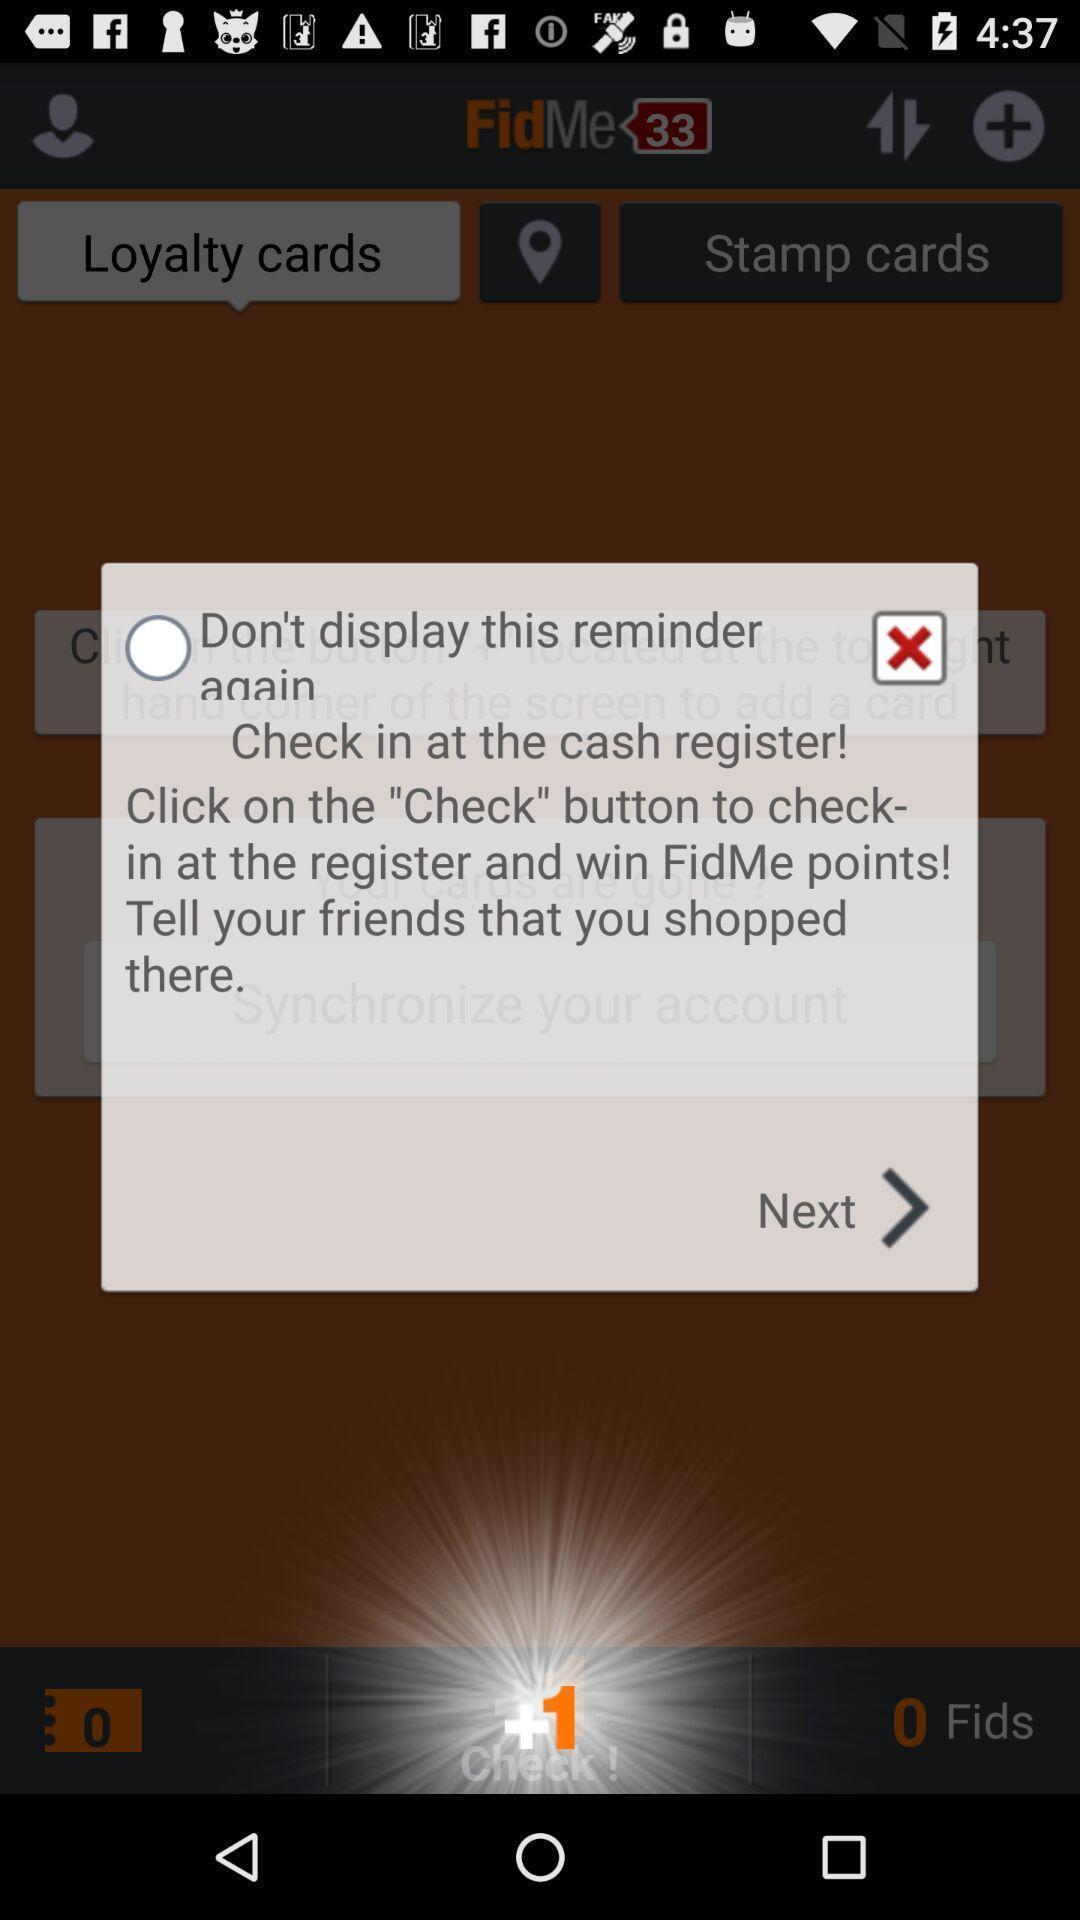Summarize the information in this screenshot. Pop-up to continue for further information. 